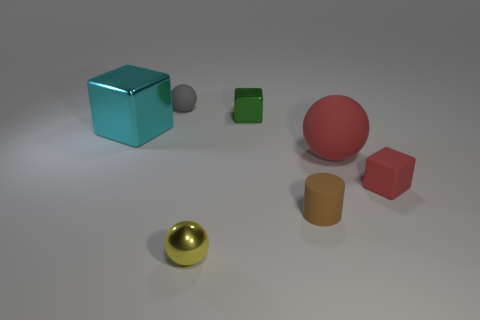What might this image be used to demonstrate or teach? This image could serve several educational purposes. It might be used to teach concepts of geometry and spatial relationships with its varied shapes like spheres, cubes, and a cylinder. It could also illustrate principles of lighting and shadow in art or photography, given the different textures and reflections on the objects. Additionally, it could be used in a color theory discussion, as the objects feature distinct and contrasting colors. 